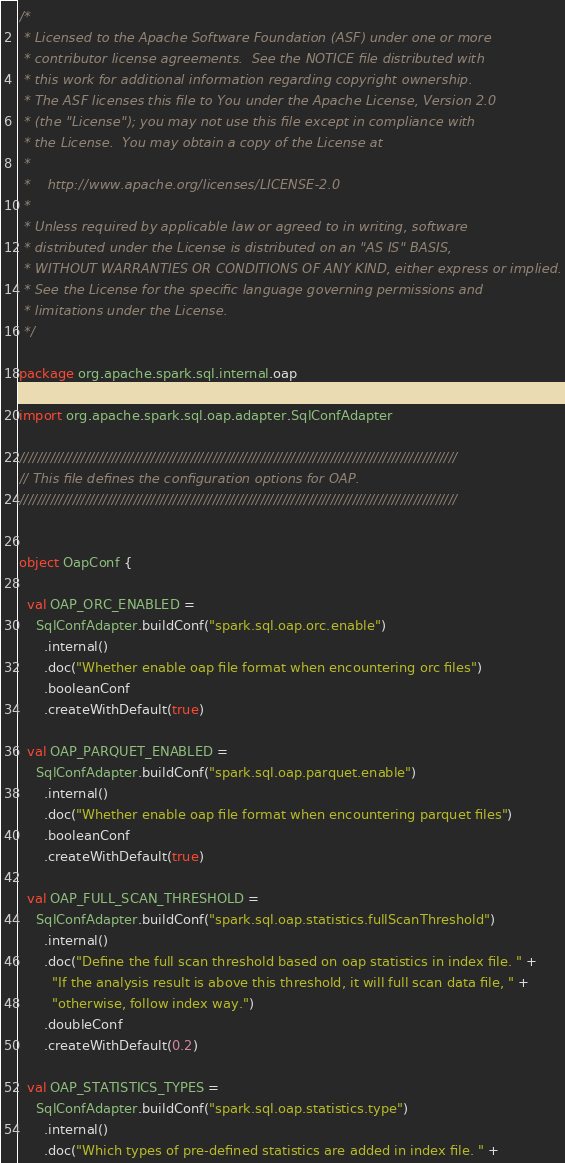Convert code to text. <code><loc_0><loc_0><loc_500><loc_500><_Scala_>/*
 * Licensed to the Apache Software Foundation (ASF) under one or more
 * contributor license agreements.  See the NOTICE file distributed with
 * this work for additional information regarding copyright ownership.
 * The ASF licenses this file to You under the Apache License, Version 2.0
 * (the "License"); you may not use this file except in compliance with
 * the License.  You may obtain a copy of the License at
 *
 *    http://www.apache.org/licenses/LICENSE-2.0
 *
 * Unless required by applicable law or agreed to in writing, software
 * distributed under the License is distributed on an "AS IS" BASIS,
 * WITHOUT WARRANTIES OR CONDITIONS OF ANY KIND, either express or implied.
 * See the License for the specific language governing permissions and
 * limitations under the License.
 */

package org.apache.spark.sql.internal.oap

import org.apache.spark.sql.oap.adapter.SqlConfAdapter

////////////////////////////////////////////////////////////////////////////////////////////////////
// This file defines the configuration options for OAP.
////////////////////////////////////////////////////////////////////////////////////////////////////


object OapConf {

  val OAP_ORC_ENABLED =
    SqlConfAdapter.buildConf("spark.sql.oap.orc.enable")
      .internal()
      .doc("Whether enable oap file format when encountering orc files")
      .booleanConf
      .createWithDefault(true)

  val OAP_PARQUET_ENABLED =
    SqlConfAdapter.buildConf("spark.sql.oap.parquet.enable")
      .internal()
      .doc("Whether enable oap file format when encountering parquet files")
      .booleanConf
      .createWithDefault(true)

  val OAP_FULL_SCAN_THRESHOLD =
    SqlConfAdapter.buildConf("spark.sql.oap.statistics.fullScanThreshold")
      .internal()
      .doc("Define the full scan threshold based on oap statistics in index file. " +
        "If the analysis result is above this threshold, it will full scan data file, " +
        "otherwise, follow index way.")
      .doubleConf
      .createWithDefault(0.2)

  val OAP_STATISTICS_TYPES =
    SqlConfAdapter.buildConf("spark.sql.oap.statistics.type")
      .internal()
      .doc("Which types of pre-defined statistics are added in index file. " +</code> 